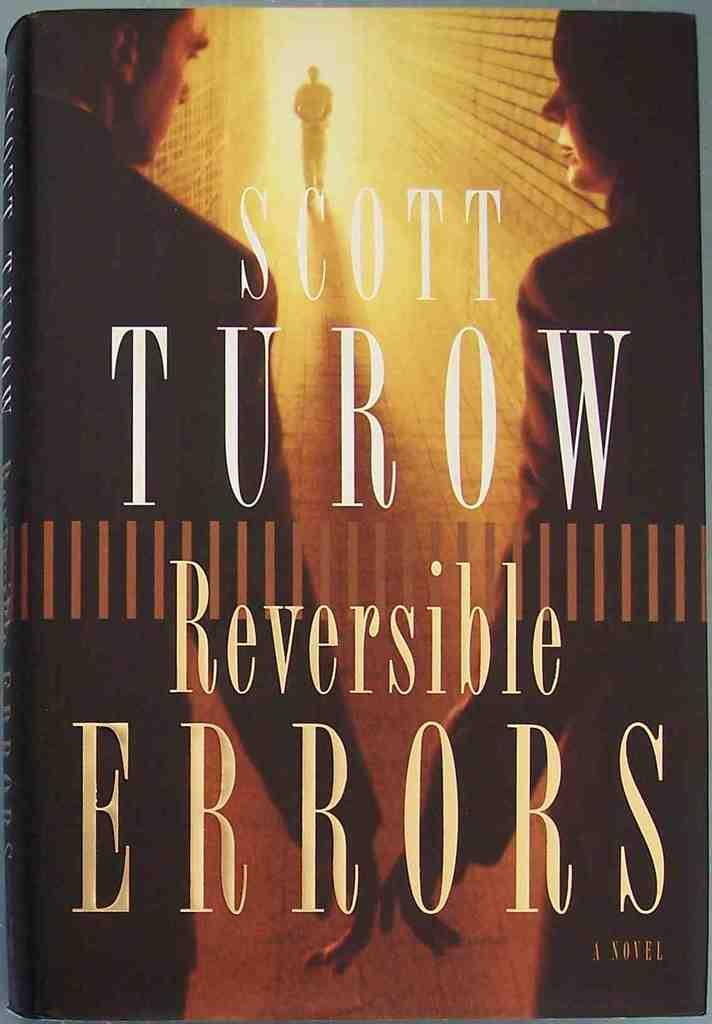<image>
Share a concise interpretation of the image provided. The novel titled Reversible Errors was written by the author Scott Turow. 